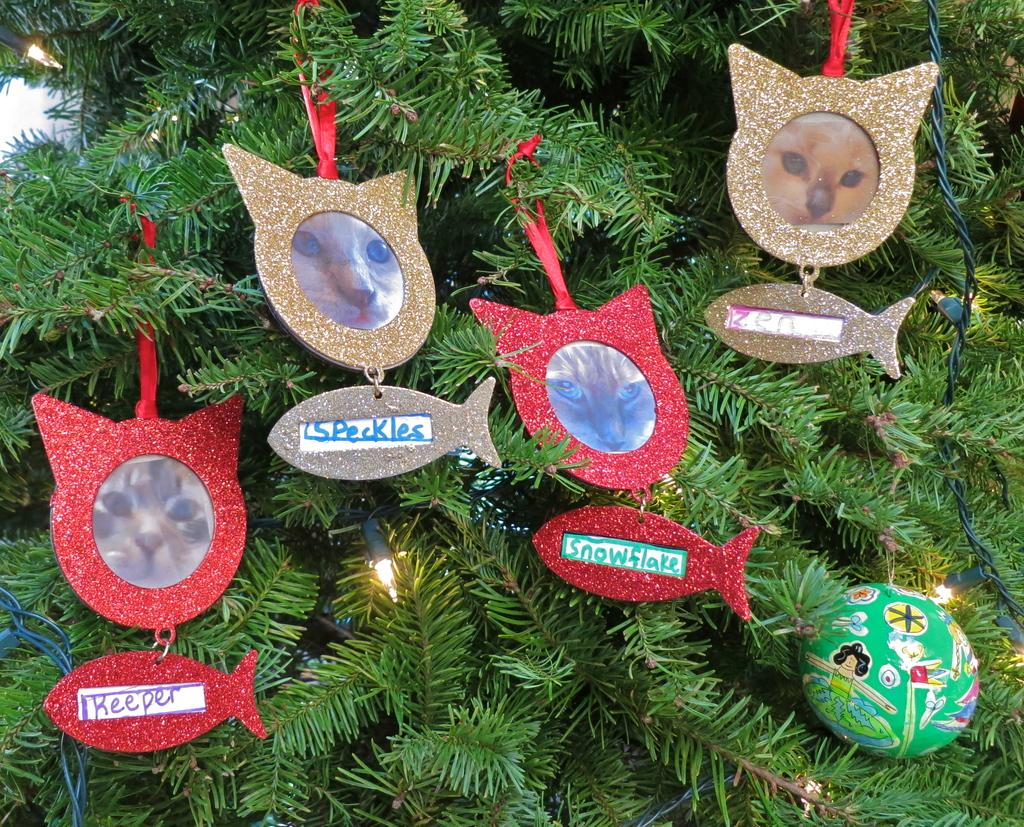What is the main object in the image? There is a Christmas tree in the image. How is the Christmas tree decorated? The Christmas tree has decoration things on it. Where is the chessboard located in the image? There is no chessboard present in the image. What type of faucet can be seen on the Christmas tree? There is no faucet present on the Christmas tree; it is a decorative object and not a functional one. 